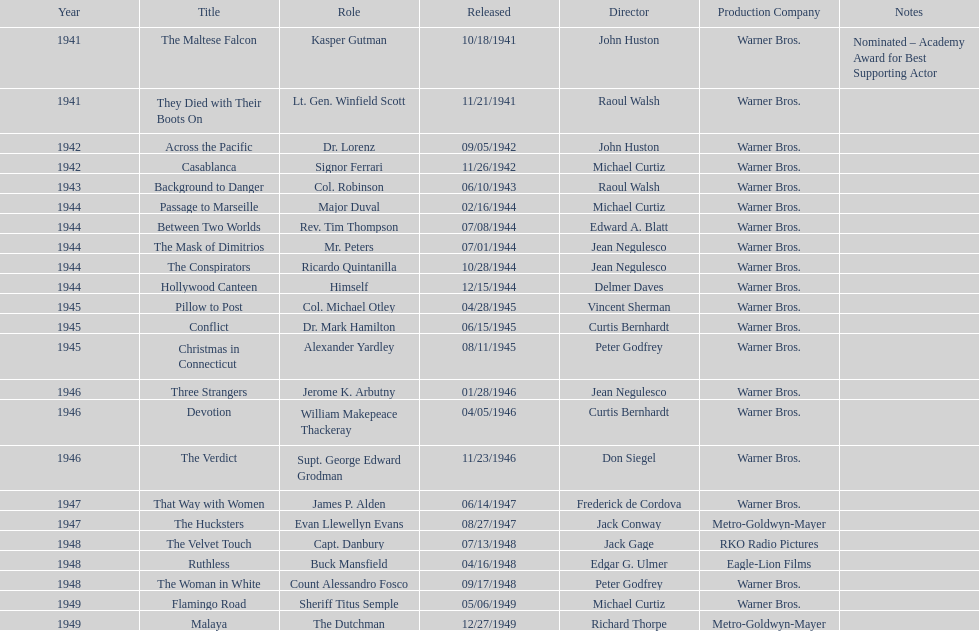In which films did greenstreet make his first and last appearances as an actor? The Maltese Falcon, Malaya. Could you help me parse every detail presented in this table? {'header': ['Year', 'Title', 'Role', 'Released', 'Director', 'Production Company', 'Notes'], 'rows': [['1941', 'The Maltese Falcon', 'Kasper Gutman', '10/18/1941', 'John Huston', 'Warner Bros.', 'Nominated – Academy Award for Best Supporting Actor'], ['1941', 'They Died with Their Boots On', 'Lt. Gen. Winfield Scott', '11/21/1941', 'Raoul Walsh', 'Warner Bros.', ''], ['1942', 'Across the Pacific', 'Dr. Lorenz', '09/05/1942', 'John Huston', 'Warner Bros.', ''], ['1942', 'Casablanca', 'Signor Ferrari', '11/26/1942', 'Michael Curtiz', 'Warner Bros.', ''], ['1943', 'Background to Danger', 'Col. Robinson', '06/10/1943', 'Raoul Walsh', 'Warner Bros.', ''], ['1944', 'Passage to Marseille', 'Major Duval', '02/16/1944', 'Michael Curtiz', 'Warner Bros.', ''], ['1944', 'Between Two Worlds', 'Rev. Tim Thompson', '07/08/1944', 'Edward A. Blatt', 'Warner Bros.', ''], ['1944', 'The Mask of Dimitrios', 'Mr. Peters', '07/01/1944', 'Jean Negulesco', 'Warner Bros.', ''], ['1944', 'The Conspirators', 'Ricardo Quintanilla', '10/28/1944', 'Jean Negulesco', 'Warner Bros.', ''], ['1944', 'Hollywood Canteen', 'Himself', '12/15/1944', 'Delmer Daves', 'Warner Bros.', ''], ['1945', 'Pillow to Post', 'Col. Michael Otley', '04/28/1945', 'Vincent Sherman', 'Warner Bros.', ''], ['1945', 'Conflict', 'Dr. Mark Hamilton', '06/15/1945', 'Curtis Bernhardt', 'Warner Bros.', ''], ['1945', 'Christmas in Connecticut', 'Alexander Yardley', '08/11/1945', 'Peter Godfrey', 'Warner Bros.', ''], ['1946', 'Three Strangers', 'Jerome K. Arbutny', '01/28/1946', 'Jean Negulesco', 'Warner Bros.', ''], ['1946', 'Devotion', 'William Makepeace Thackeray', '04/05/1946', 'Curtis Bernhardt', 'Warner Bros.', ''], ['1946', 'The Verdict', 'Supt. George Edward Grodman', '11/23/1946', 'Don Siegel', 'Warner Bros.', ''], ['1947', 'That Way with Women', 'James P. Alden', '06/14/1947', 'Frederick de Cordova', 'Warner Bros.', ''], ['1947', 'The Hucksters', 'Evan Llewellyn Evans', '08/27/1947', 'Jack Conway', 'Metro-Goldwyn-Mayer', ''], ['1948', 'The Velvet Touch', 'Capt. Danbury', '07/13/1948', 'Jack Gage', 'RKO Radio Pictures', ''], ['1948', 'Ruthless', 'Buck Mansfield', '04/16/1948', 'Edgar G. Ulmer', 'Eagle-Lion Films', ''], ['1948', 'The Woman in White', 'Count Alessandro Fosco', '09/17/1948', 'Peter Godfrey', 'Warner Bros.', ''], ['1949', 'Flamingo Road', 'Sheriff Titus Semple', '05/06/1949', 'Michael Curtiz', 'Warner Bros.', ''], ['1949', 'Malaya', 'The Dutchman', '12/27/1949', 'Richard Thorpe', 'Metro-Goldwyn-Mayer', '']]} 